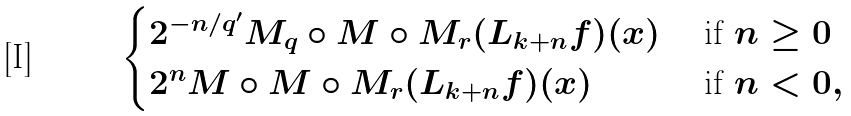<formula> <loc_0><loc_0><loc_500><loc_500>\begin{cases} 2 ^ { - n / q ^ { \prime } } M _ { q } \circ M \circ M _ { r } ( L _ { k + n } f ) ( x ) & \text { if } n \geq 0 \\ 2 ^ { n } M \circ M \circ M _ { r } ( L _ { k + n } f ) ( x ) & \text { if } n < 0 , \end{cases}</formula> 